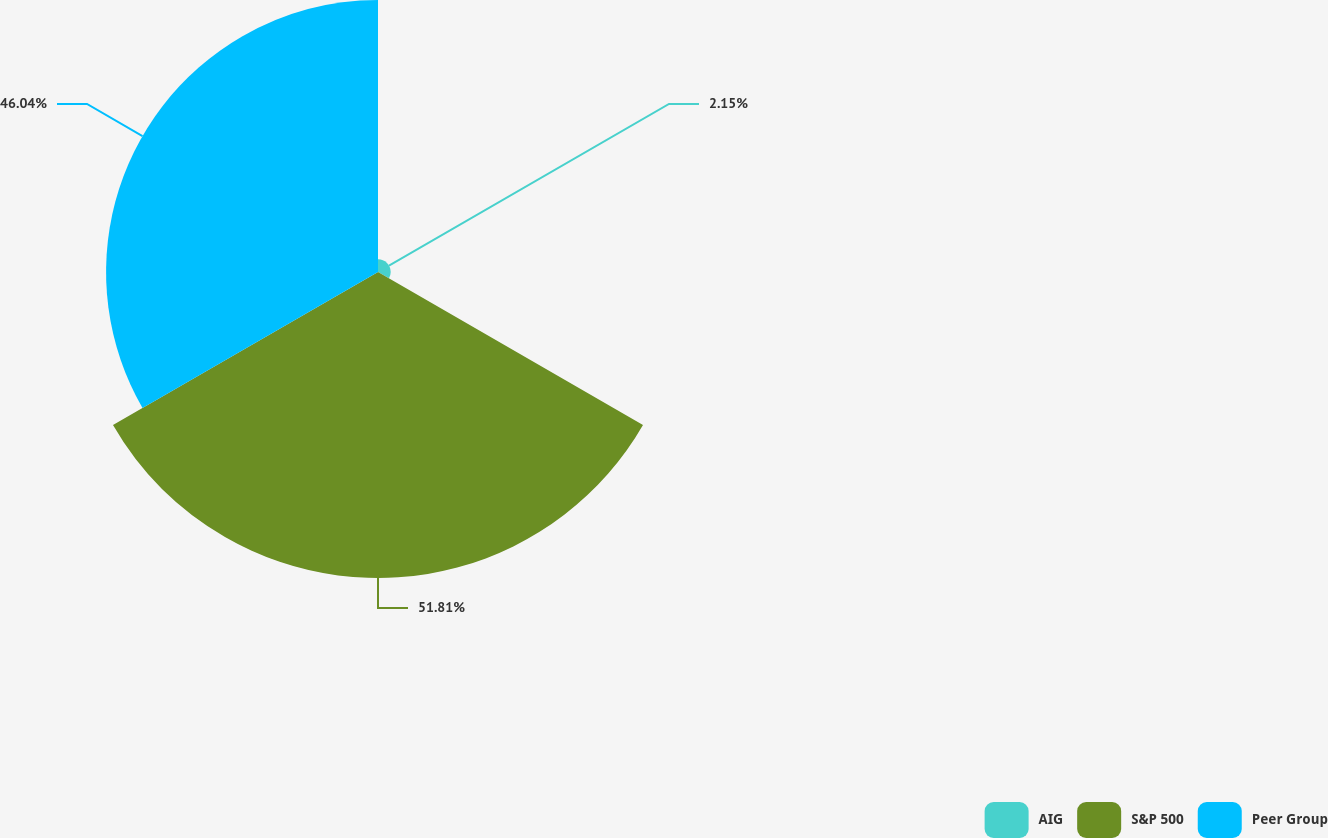<chart> <loc_0><loc_0><loc_500><loc_500><pie_chart><fcel>AIG<fcel>S&P 500<fcel>Peer Group<nl><fcel>2.15%<fcel>51.81%<fcel>46.04%<nl></chart> 